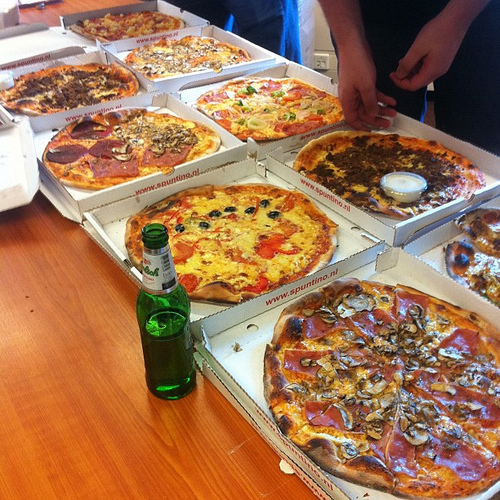How many pizzas can you see in this image? There are eight pizzas in this image. What toppings are on the pizza in the center of the image? The pizza in the center of the image has toppings that include olives, red peppers, and cheese. If you were to arrange these pizzas by size, which one would be the largest? It appears that the pizza in the bottom right corner is the largest, as it seems to take up more space and its toppings are spread broadly. 